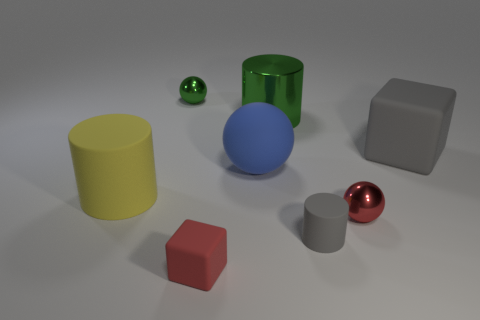Subtract all big cylinders. How many cylinders are left? 1 Subtract all green balls. How many balls are left? 2 Add 2 blue objects. How many objects exist? 10 Subtract all cubes. How many objects are left? 6 Subtract all yellow cylinders. How many green balls are left? 1 Subtract all big purple matte objects. Subtract all big yellow cylinders. How many objects are left? 7 Add 3 red things. How many red things are left? 5 Add 3 rubber blocks. How many rubber blocks exist? 5 Subtract 1 green cylinders. How many objects are left? 7 Subtract 1 cylinders. How many cylinders are left? 2 